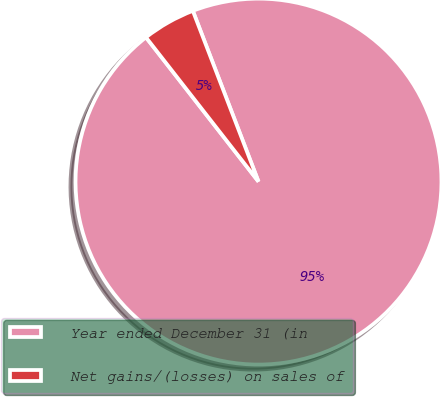<chart> <loc_0><loc_0><loc_500><loc_500><pie_chart><fcel>Year ended December 31 (in<fcel>Net gains/(losses) on sales of<nl><fcel>95.3%<fcel>4.7%<nl></chart> 